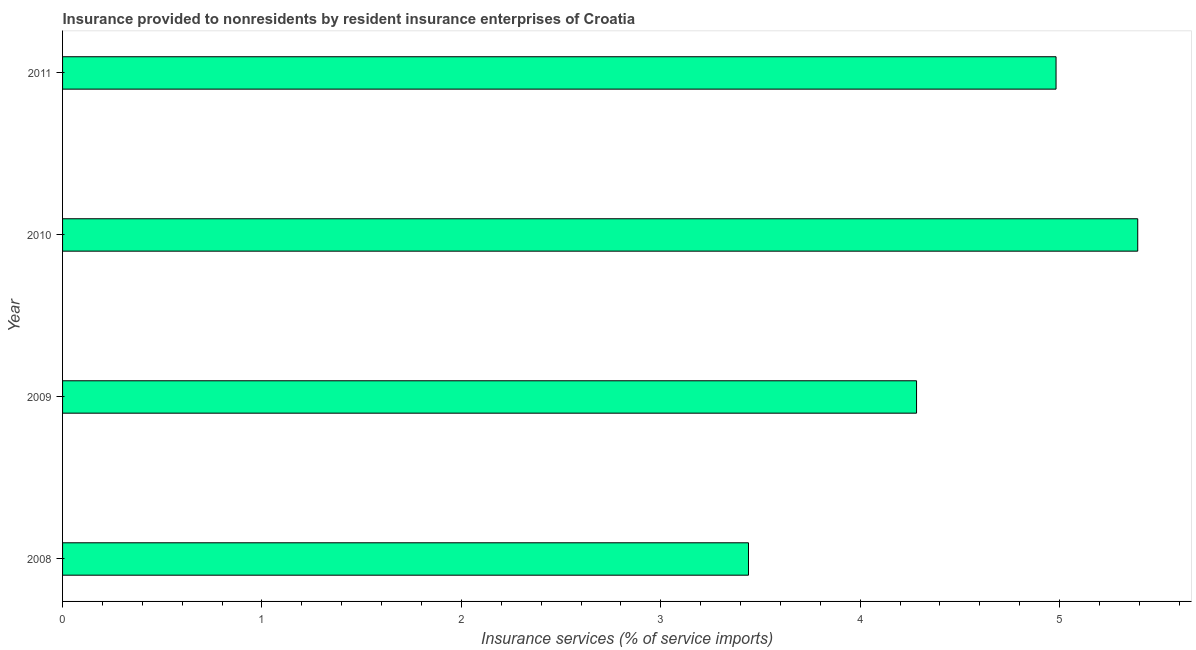What is the title of the graph?
Provide a short and direct response. Insurance provided to nonresidents by resident insurance enterprises of Croatia. What is the label or title of the X-axis?
Your answer should be compact. Insurance services (% of service imports). What is the label or title of the Y-axis?
Give a very brief answer. Year. What is the insurance and financial services in 2008?
Your answer should be very brief. 3.44. Across all years, what is the maximum insurance and financial services?
Keep it short and to the point. 5.39. Across all years, what is the minimum insurance and financial services?
Ensure brevity in your answer.  3.44. In which year was the insurance and financial services maximum?
Your answer should be compact. 2010. What is the sum of the insurance and financial services?
Your answer should be compact. 18.1. What is the difference between the insurance and financial services in 2010 and 2011?
Ensure brevity in your answer.  0.41. What is the average insurance and financial services per year?
Provide a short and direct response. 4.52. What is the median insurance and financial services?
Your response must be concise. 4.63. In how many years, is the insurance and financial services greater than 0.6 %?
Your response must be concise. 4. Do a majority of the years between 2008 and 2010 (inclusive) have insurance and financial services greater than 1 %?
Ensure brevity in your answer.  Yes. What is the ratio of the insurance and financial services in 2008 to that in 2010?
Keep it short and to the point. 0.64. Is the insurance and financial services in 2010 less than that in 2011?
Your response must be concise. No. Is the difference between the insurance and financial services in 2009 and 2011 greater than the difference between any two years?
Give a very brief answer. No. What is the difference between the highest and the second highest insurance and financial services?
Offer a terse response. 0.41. Is the sum of the insurance and financial services in 2008 and 2010 greater than the maximum insurance and financial services across all years?
Ensure brevity in your answer.  Yes. What is the difference between the highest and the lowest insurance and financial services?
Offer a terse response. 1.95. In how many years, is the insurance and financial services greater than the average insurance and financial services taken over all years?
Your answer should be very brief. 2. How many years are there in the graph?
Your answer should be very brief. 4. What is the Insurance services (% of service imports) in 2008?
Offer a terse response. 3.44. What is the Insurance services (% of service imports) in 2009?
Provide a succinct answer. 4.28. What is the Insurance services (% of service imports) in 2010?
Your answer should be compact. 5.39. What is the Insurance services (% of service imports) in 2011?
Make the answer very short. 4.98. What is the difference between the Insurance services (% of service imports) in 2008 and 2009?
Provide a succinct answer. -0.84. What is the difference between the Insurance services (% of service imports) in 2008 and 2010?
Give a very brief answer. -1.95. What is the difference between the Insurance services (% of service imports) in 2008 and 2011?
Provide a succinct answer. -1.54. What is the difference between the Insurance services (% of service imports) in 2009 and 2010?
Ensure brevity in your answer.  -1.11. What is the difference between the Insurance services (% of service imports) in 2009 and 2011?
Provide a short and direct response. -0.7. What is the difference between the Insurance services (% of service imports) in 2010 and 2011?
Ensure brevity in your answer.  0.41. What is the ratio of the Insurance services (% of service imports) in 2008 to that in 2009?
Your answer should be very brief. 0.8. What is the ratio of the Insurance services (% of service imports) in 2008 to that in 2010?
Give a very brief answer. 0.64. What is the ratio of the Insurance services (% of service imports) in 2008 to that in 2011?
Offer a very short reply. 0.69. What is the ratio of the Insurance services (% of service imports) in 2009 to that in 2010?
Offer a terse response. 0.79. What is the ratio of the Insurance services (% of service imports) in 2009 to that in 2011?
Your answer should be very brief. 0.86. What is the ratio of the Insurance services (% of service imports) in 2010 to that in 2011?
Your answer should be compact. 1.08. 